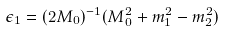<formula> <loc_0><loc_0><loc_500><loc_500>\epsilon _ { 1 } = ( 2 M _ { 0 } ) ^ { - 1 } ( M _ { 0 } ^ { 2 } + m _ { 1 } ^ { 2 } - m _ { 2 } ^ { 2 } )</formula> 